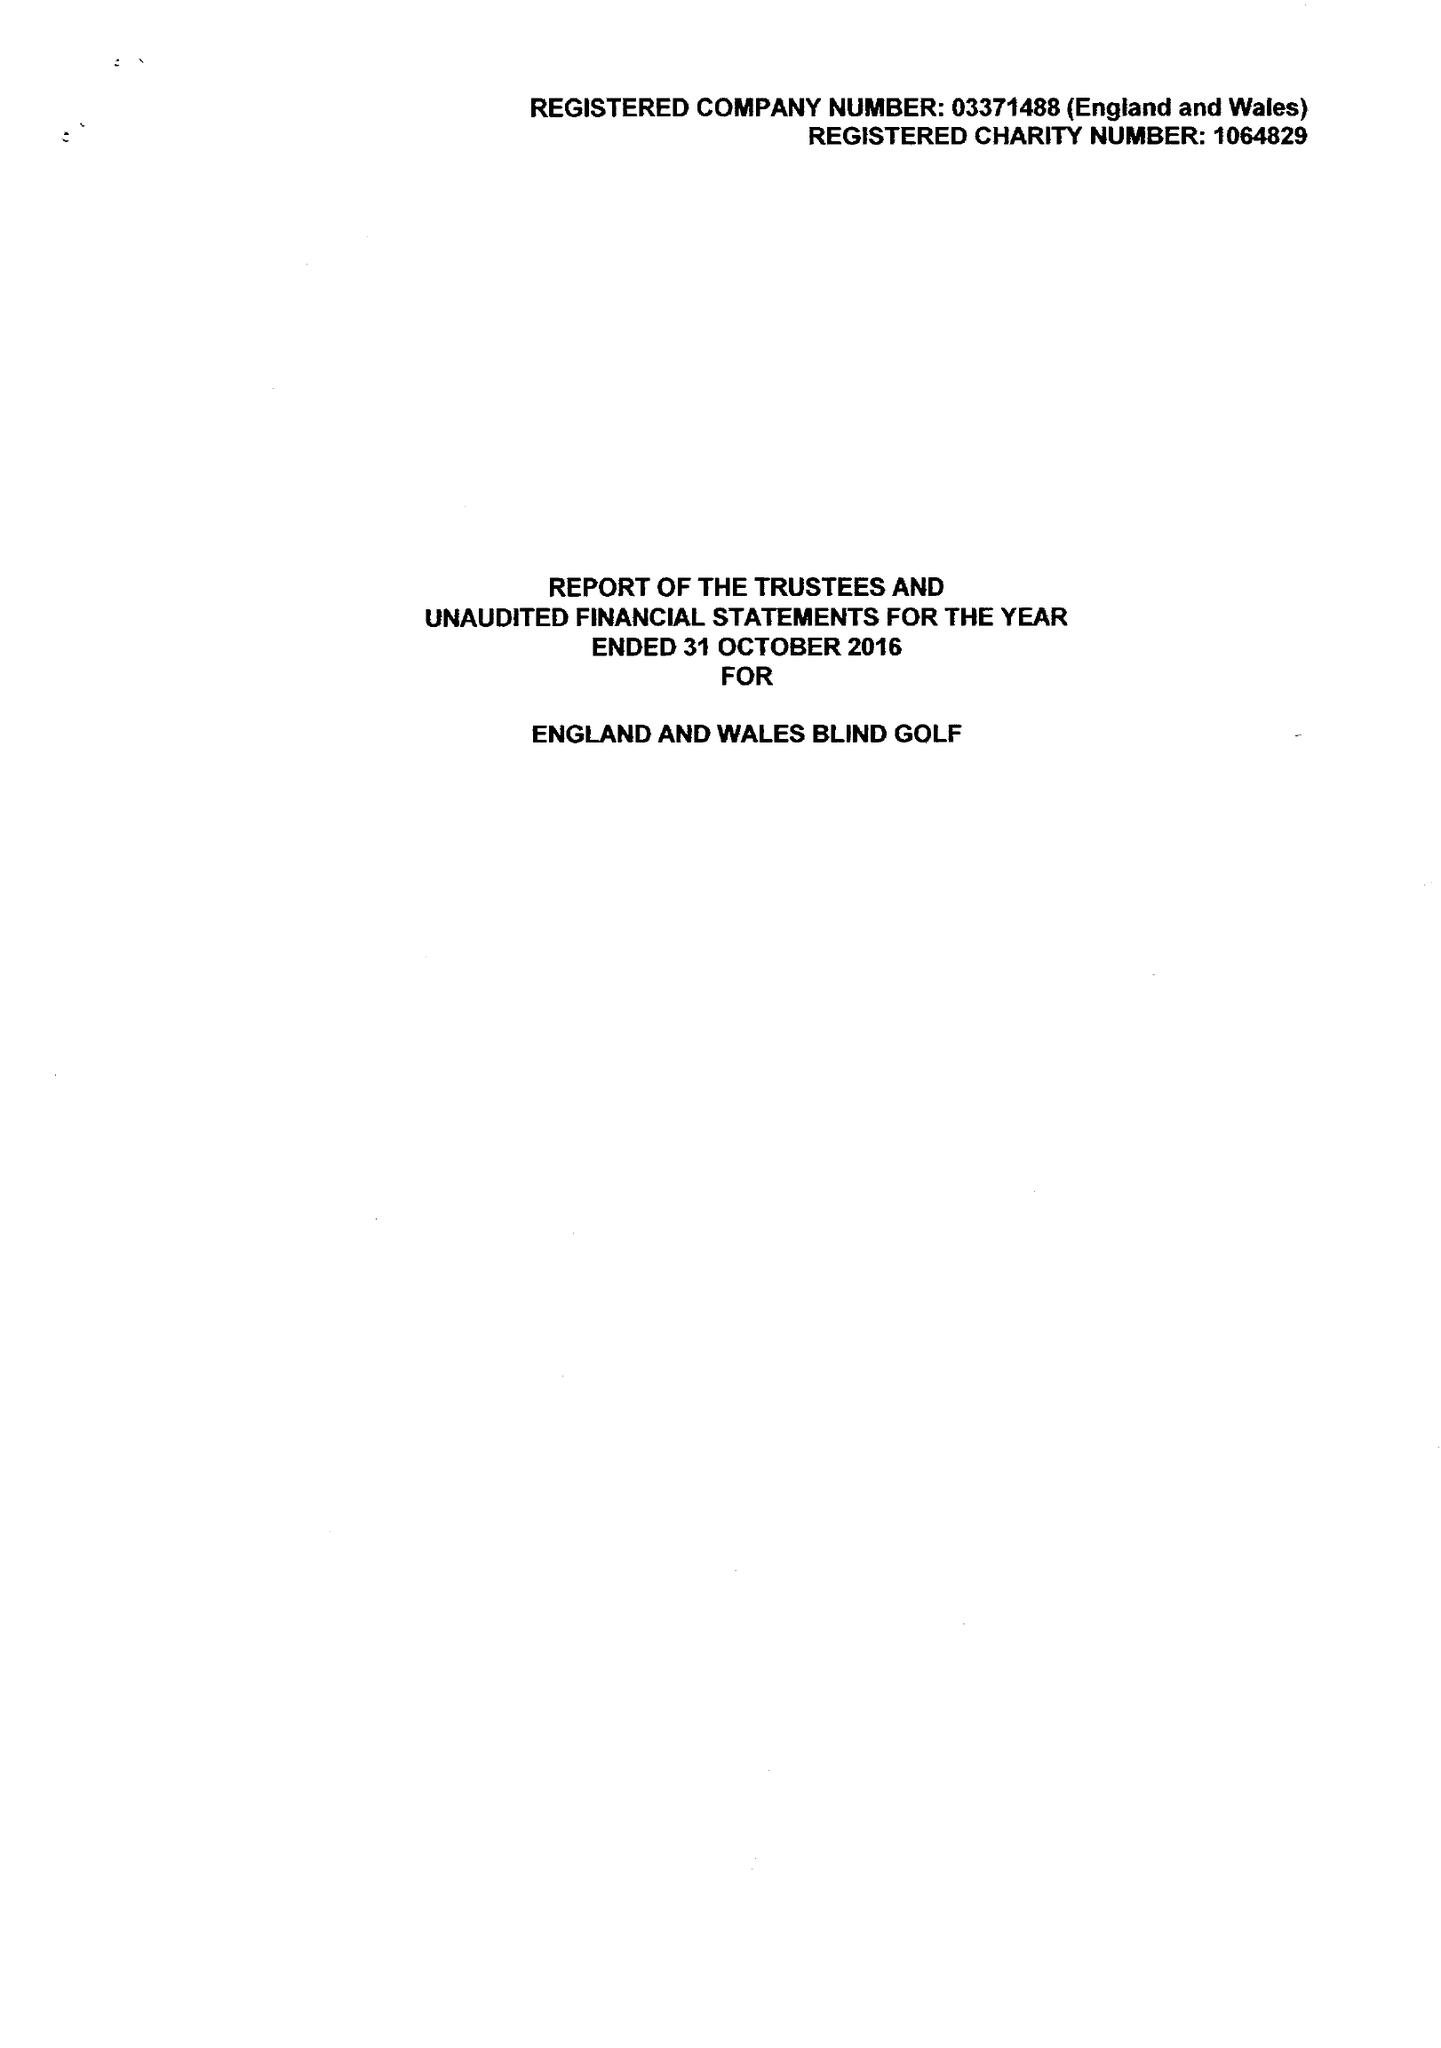What is the value for the spending_annually_in_british_pounds?
Answer the question using a single word or phrase. 109233.00 